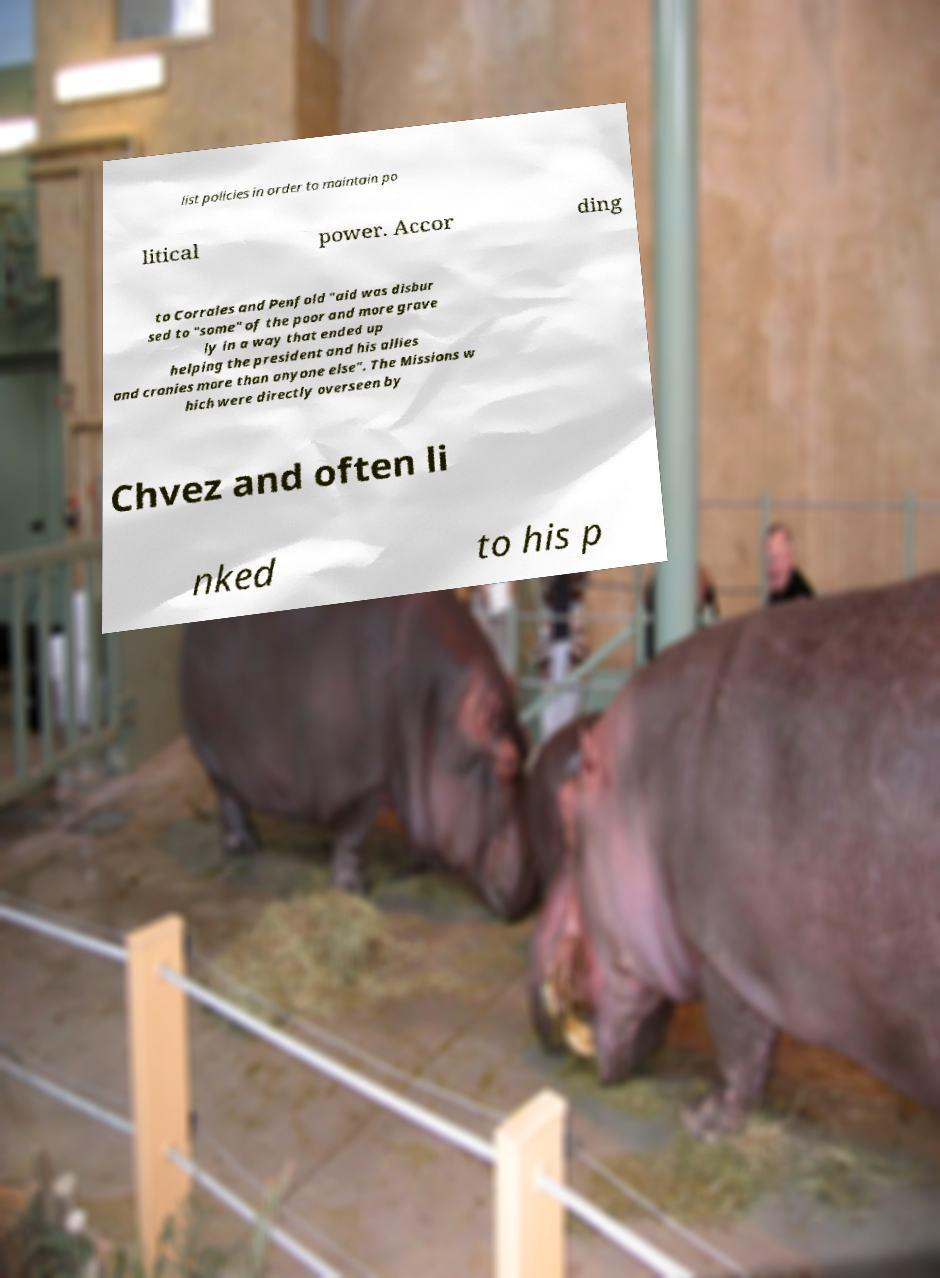What messages or text are displayed in this image? I need them in a readable, typed format. list policies in order to maintain po litical power. Accor ding to Corrales and Penfold "aid was disbur sed to "some" of the poor and more grave ly in a way that ended up helping the president and his allies and cronies more than anyone else". The Missions w hich were directly overseen by Chvez and often li nked to his p 